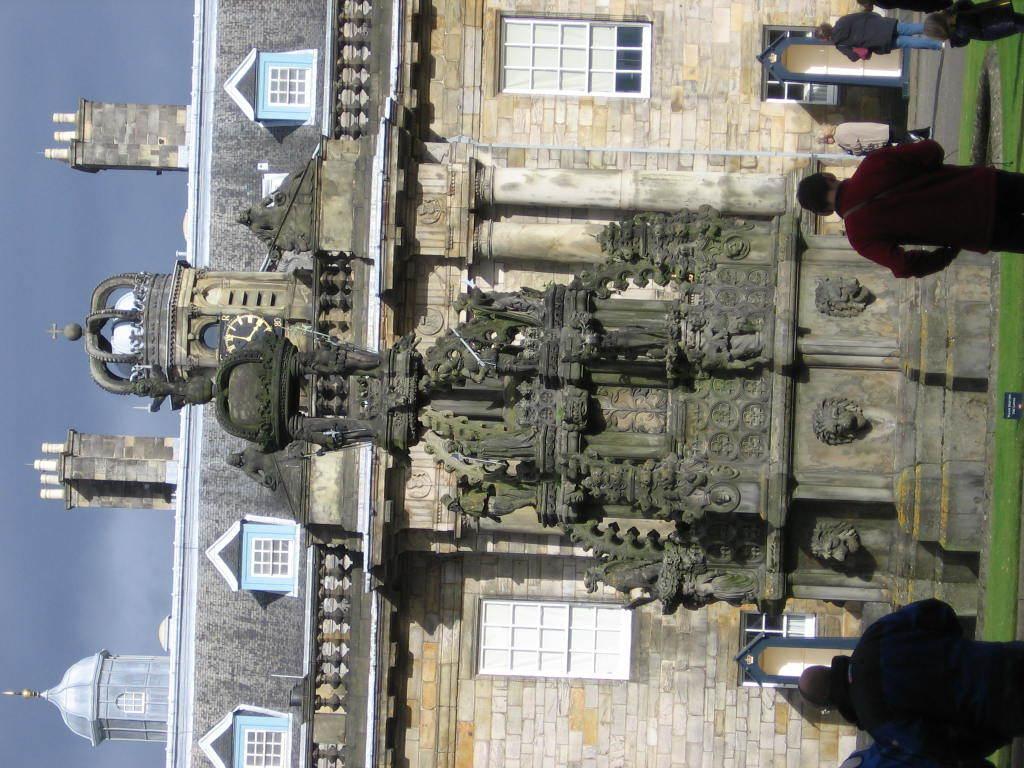How would you summarize this image in a sentence or two? In this picture we can see few buildings and group of people, and also we can see grass. 